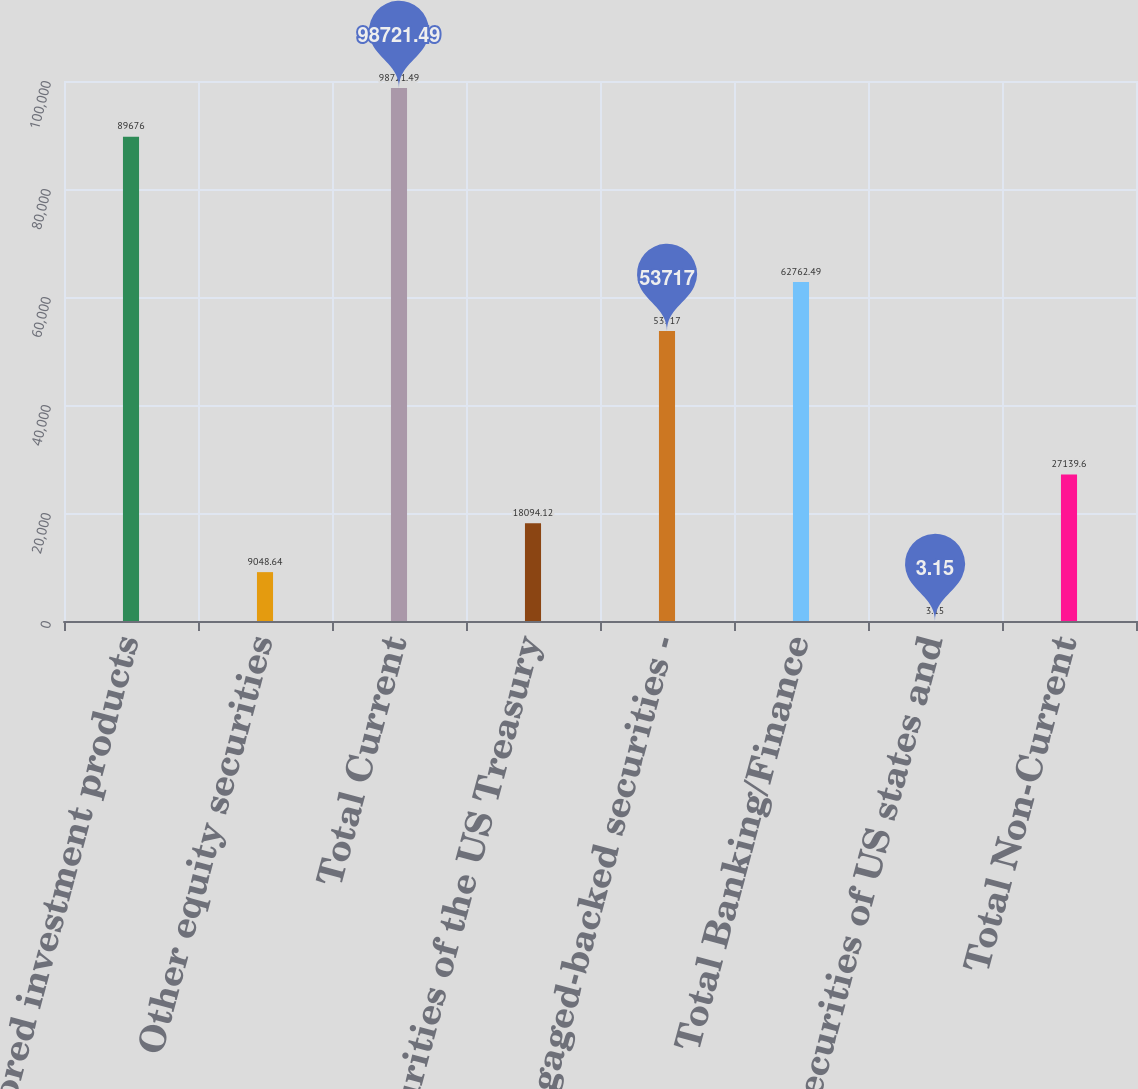Convert chart. <chart><loc_0><loc_0><loc_500><loc_500><bar_chart><fcel>Sponsored investment products<fcel>Other equity securities<fcel>Total Current<fcel>Securities of the US Treasury<fcel>Mortgaged-backed securities -<fcel>Total Banking/Finance<fcel>Securities of US states and<fcel>Total Non-Current<nl><fcel>89676<fcel>9048.64<fcel>98721.5<fcel>18094.1<fcel>53717<fcel>62762.5<fcel>3.15<fcel>27139.6<nl></chart> 